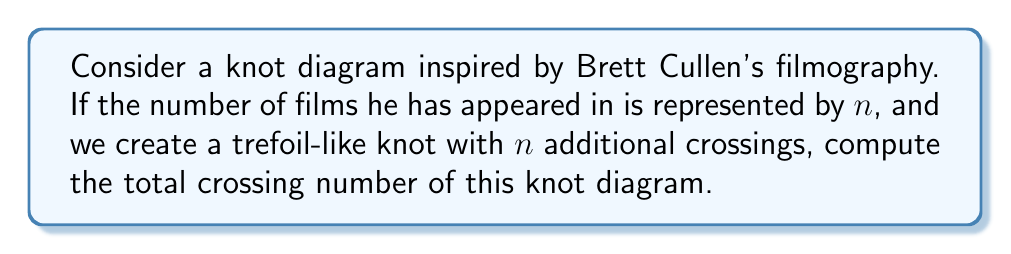Can you solve this math problem? To solve this problem, we need to follow these steps:

1. Determine the number of films Brett Cullen has appeared in:
   Brett Cullen has appeared in approximately 100 films and TV shows.

2. Recall the crossing number of a standard trefoil knot:
   A trefoil knot has a crossing number of 3.

3. Add the additional crossings based on Brett Cullen's filmography:
   We add $n = 100$ crossings to the trefoil knot.

4. Calculate the total crossing number:
   $$\text{Total crossing number} = \text{Trefoil crossings} + \text{Additional crossings}$$
   $$\text{Total crossing number} = 3 + 100 = 103$$

Thus, the knot diagram inspired by Brett Cullen's filmography would have a total of 103 crossings.
Answer: 103 